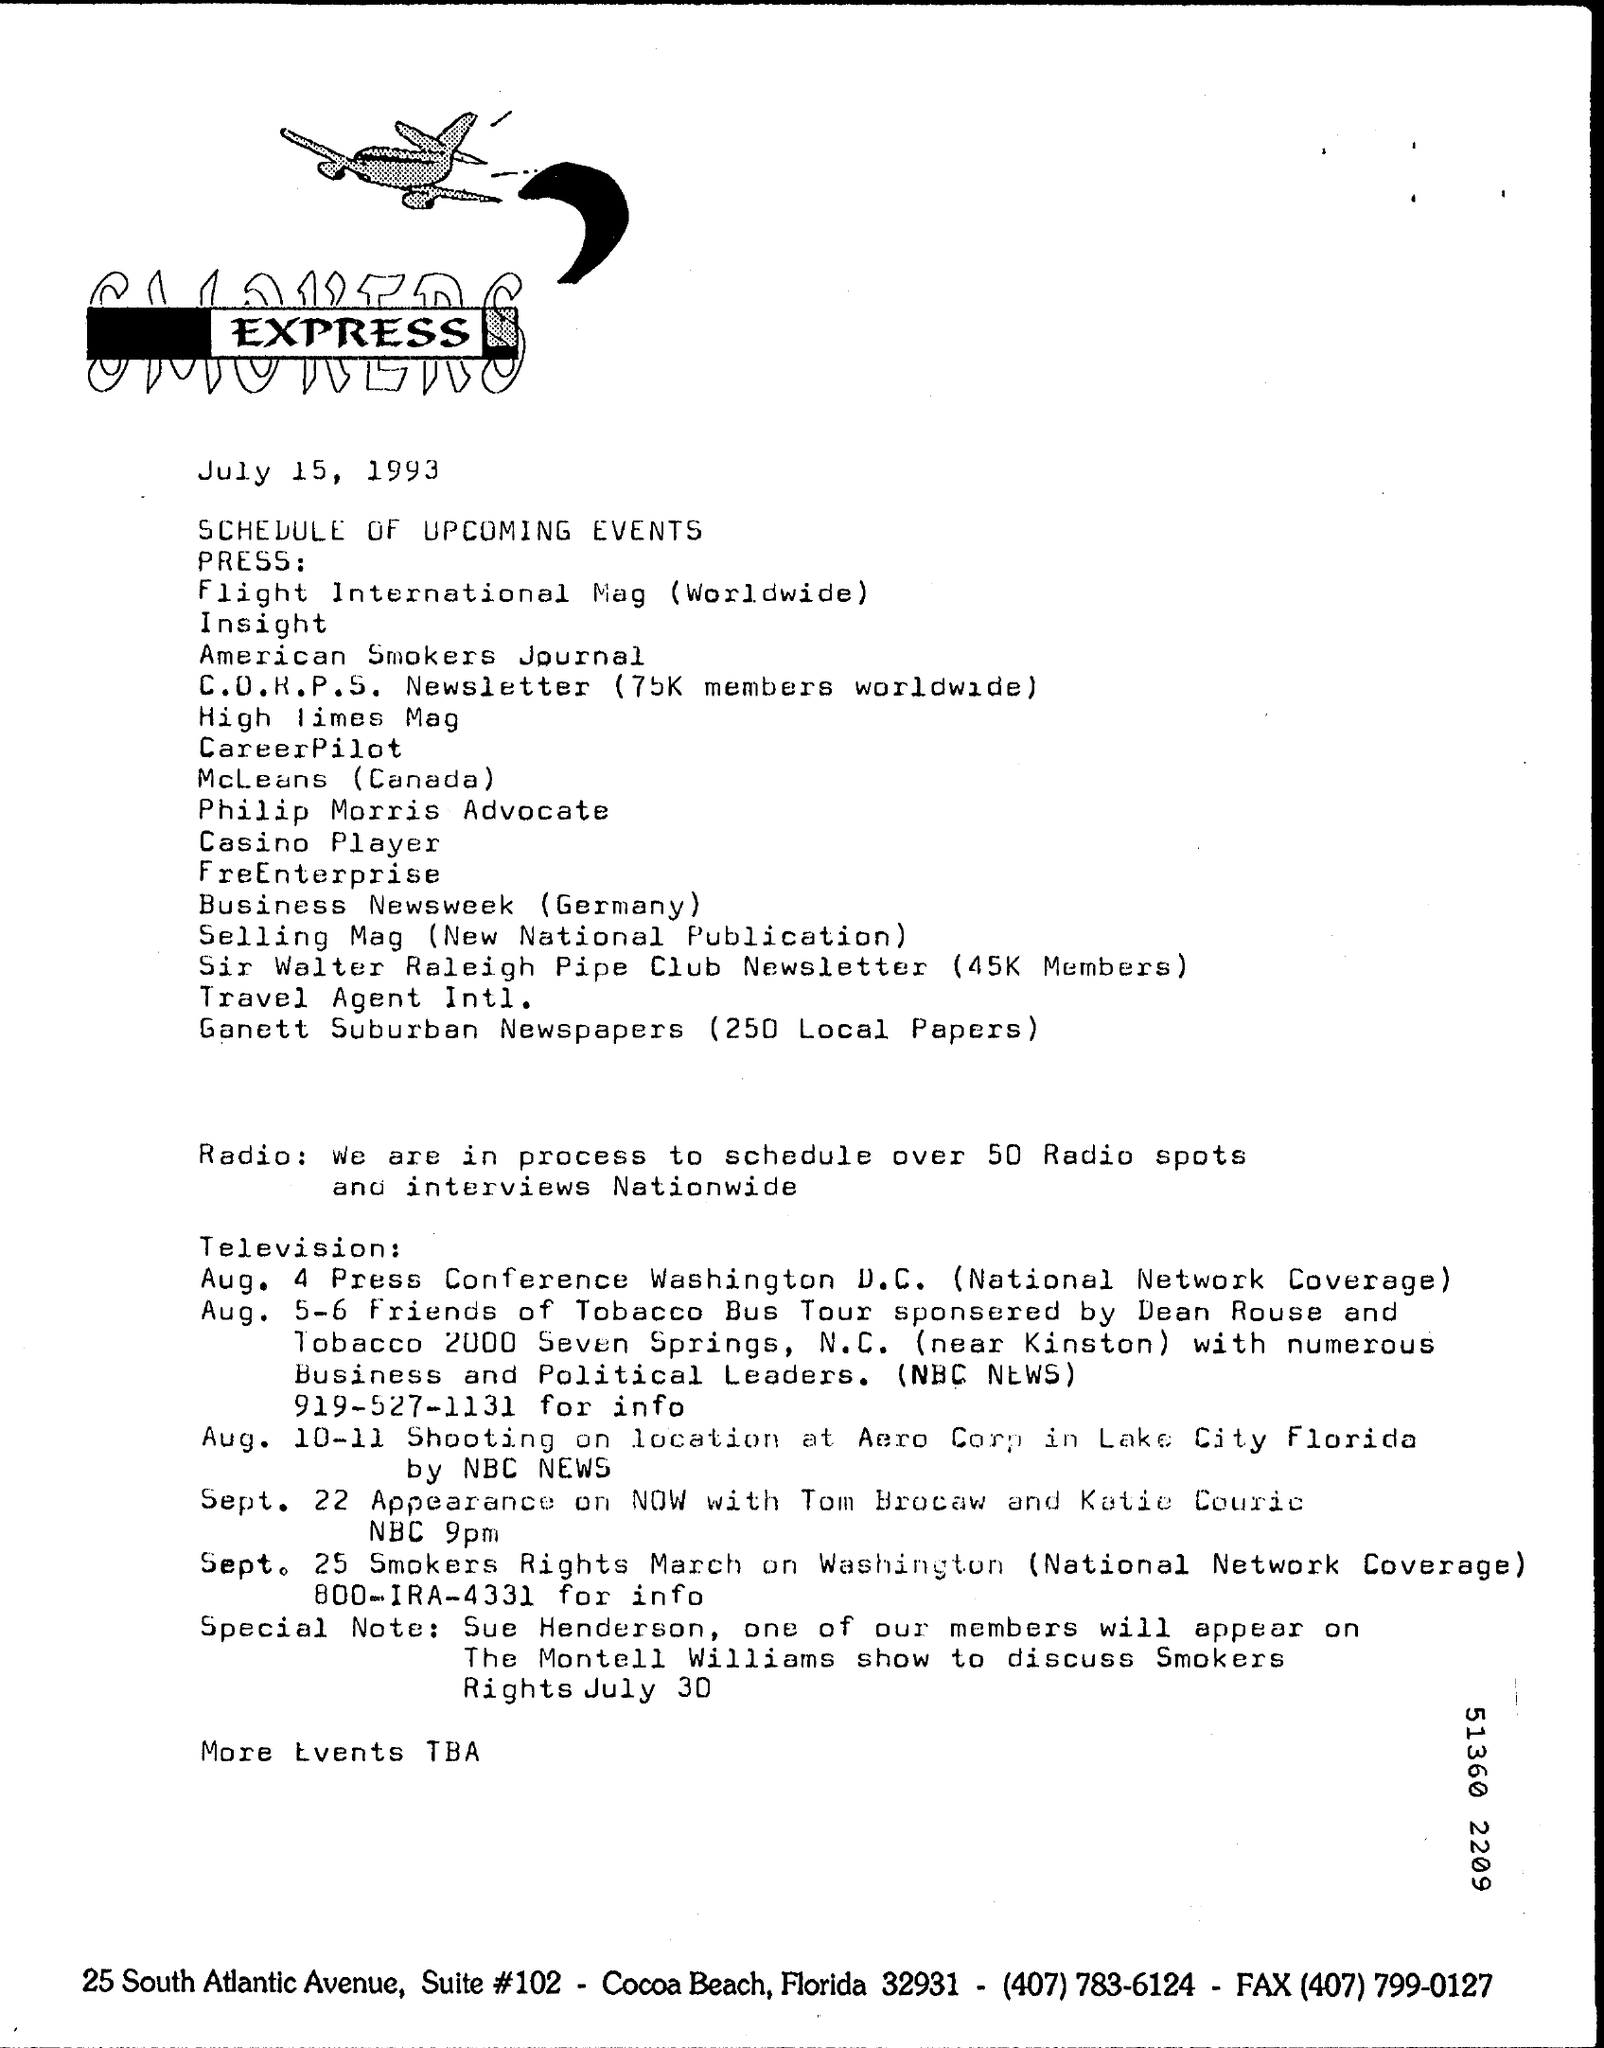List a handful of essential elements in this visual. The press conference in Washington D.C. is scheduled for August 4th. The fax number is (407) 799-0127. 